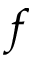Convert formula to latex. <formula><loc_0><loc_0><loc_500><loc_500>f</formula> 